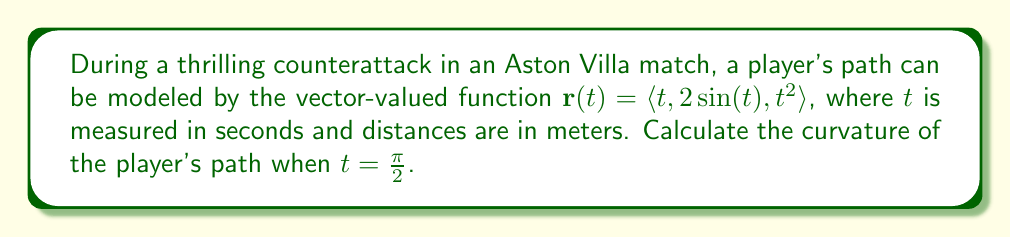Help me with this question. To find the curvature of the player's path, we'll use the formula for curvature of a vector-valued function:

$$\kappa = \frac{|\mathbf{r}'(t) \times \mathbf{r}''(t)|}{|\mathbf{r}'(t)|^3}$$

Let's break this down step-by-step:

1) First, we need to find $\mathbf{r}'(t)$ and $\mathbf{r}''(t)$:

   $\mathbf{r}'(t) = \langle 1, 2\cos(t), 2t \rangle$
   $\mathbf{r}''(t) = \langle 0, -2\sin(t), 2 \rangle$

2) Now, let's calculate $\mathbf{r}'(t) \times \mathbf{r}''(t)$:

   $\mathbf{r}'(t) \times \mathbf{r}''(t) = \begin{vmatrix} 
   \mathbf{i} & \mathbf{j} & \mathbf{k} \\
   1 & 2\cos(t) & 2t \\
   0 & -2\sin(t) & 2
   \end{vmatrix}$

   $= \langle 4\cos(t) - 4t\sin(t), -2, 2\sin(t) \rangle$

3) Now we can calculate $|\mathbf{r}'(t) \times \mathbf{r}''(t)|$:

   $|\mathbf{r}'(t) \times \mathbf{r}''(t)| = \sqrt{(4\cos(t) - 4t\sin(t))^2 + (-2)^2 + (2\sin(t))^2}$

4) We also need $|\mathbf{r}'(t)|^3$:

   $|\mathbf{r}'(t)| = \sqrt{1^2 + (2\cos(t))^2 + (2t)^2} = \sqrt{1 + 4\cos^2(t) + 4t^2}$

   $|\mathbf{r}'(t)|^3 = (1 + 4\cos^2(t) + 4t^2)^{3/2}$

5) Now, let's substitute $t = \frac{\pi}{2}$:

   $|\mathbf{r}'(\frac{\pi}{2}) \times \mathbf{r}''(\frac{\pi}{2})| = \sqrt{(4\cos(\frac{\pi}{2}) - 4\frac{\pi}{2}\sin(\frac{\pi}{2}))^2 + (-2)^2 + (2\sin(\frac{\pi}{2}))^2}$
   $= \sqrt{(-2\pi)^2 + (-2)^2 + 2^2} = \sqrt{4\pi^2 + 8}$

   $|\mathbf{r}'(\frac{\pi}{2})|^3 = (1 + 4\cos^2(\frac{\pi}{2}) + 4(\frac{\pi}{2})^2)^{3/2} = (1 + \pi^2)^{3/2}$

6) Finally, we can calculate the curvature:

   $\kappa = \frac{\sqrt{4\pi^2 + 8}}{(1 + \pi^2)^{3/2}}$

This is the curvature of the player's path at $t = \frac{\pi}{2}$ seconds.
Answer: $\kappa = \frac{\sqrt{4\pi^2 + 8}}{(1 + \pi^2)^{3/2}}$ 